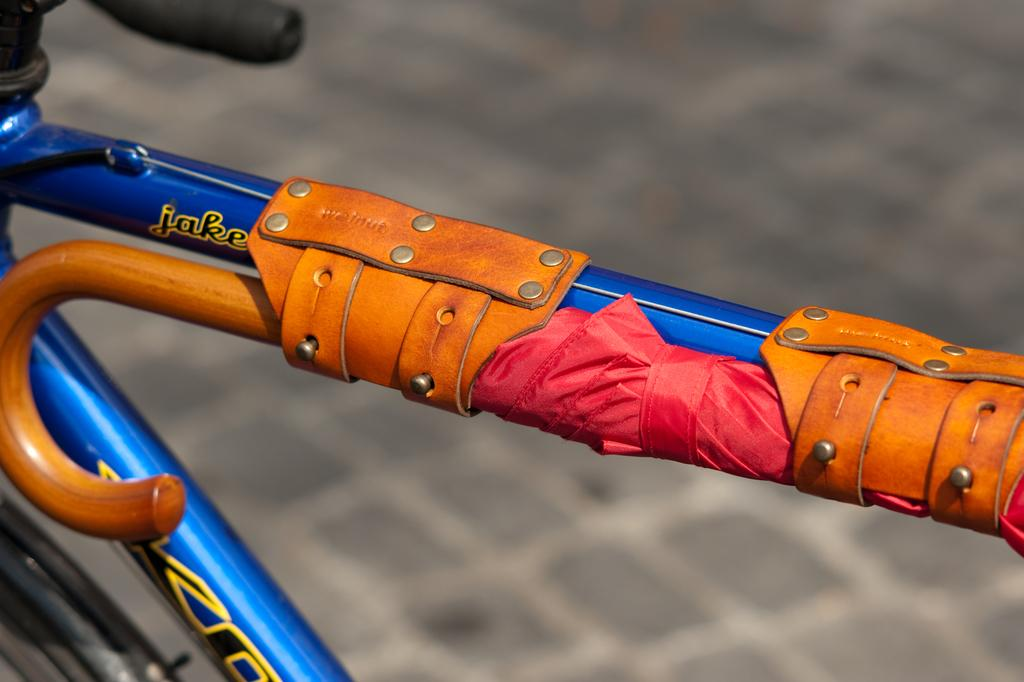What is the main object in the image? There is a bicycle in the image. Where is the bicycle located? The bicycle is on the floor. What other object can be seen in the image? There is an umbrella in the image. How is the umbrella connected to the bicycle? The umbrella is tied to the metal rod of the bicycle. What type of sidewalk can be seen in the image? There is no sidewalk present in the image. How does the umbrella twist around the metal rod of the bicycle? The umbrella is not shown twisting around the metal rod of the bicycle in the image. 